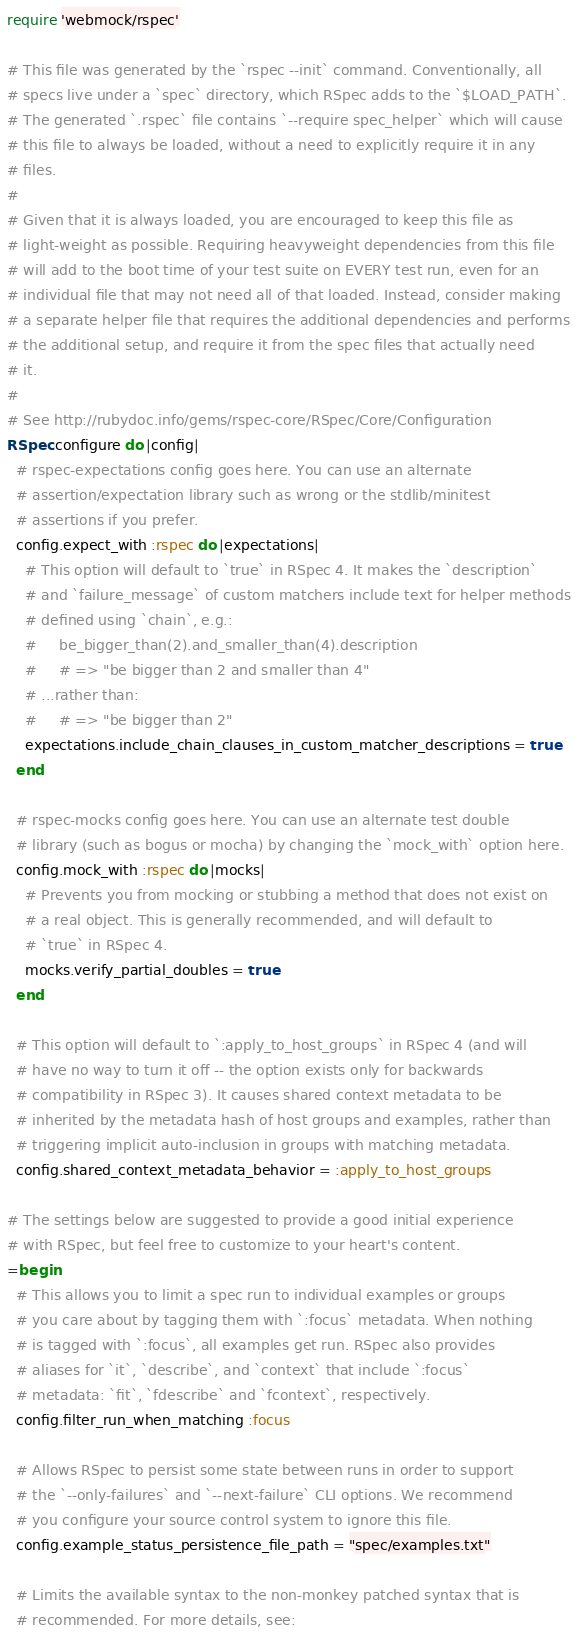Convert code to text. <code><loc_0><loc_0><loc_500><loc_500><_Ruby_>require 'webmock/rspec'

# This file was generated by the `rspec --init` command. Conventionally, all
# specs live under a `spec` directory, which RSpec adds to the `$LOAD_PATH`.
# The generated `.rspec` file contains `--require spec_helper` which will cause
# this file to always be loaded, without a need to explicitly require it in any
# files.
#
# Given that it is always loaded, you are encouraged to keep this file as
# light-weight as possible. Requiring heavyweight dependencies from this file
# will add to the boot time of your test suite on EVERY test run, even for an
# individual file that may not need all of that loaded. Instead, consider making
# a separate helper file that requires the additional dependencies and performs
# the additional setup, and require it from the spec files that actually need
# it.
#
# See http://rubydoc.info/gems/rspec-core/RSpec/Core/Configuration
RSpec.configure do |config|
  # rspec-expectations config goes here. You can use an alternate
  # assertion/expectation library such as wrong or the stdlib/minitest
  # assertions if you prefer.
  config.expect_with :rspec do |expectations|
    # This option will default to `true` in RSpec 4. It makes the `description`
    # and `failure_message` of custom matchers include text for helper methods
    # defined using `chain`, e.g.:
    #     be_bigger_than(2).and_smaller_than(4).description
    #     # => "be bigger than 2 and smaller than 4"
    # ...rather than:
    #     # => "be bigger than 2"
    expectations.include_chain_clauses_in_custom_matcher_descriptions = true
  end

  # rspec-mocks config goes here. You can use an alternate test double
  # library (such as bogus or mocha) by changing the `mock_with` option here.
  config.mock_with :rspec do |mocks|
    # Prevents you from mocking or stubbing a method that does not exist on
    # a real object. This is generally recommended, and will default to
    # `true` in RSpec 4.
    mocks.verify_partial_doubles = true
  end

  # This option will default to `:apply_to_host_groups` in RSpec 4 (and will
  # have no way to turn it off -- the option exists only for backwards
  # compatibility in RSpec 3). It causes shared context metadata to be
  # inherited by the metadata hash of host groups and examples, rather than
  # triggering implicit auto-inclusion in groups with matching metadata.
  config.shared_context_metadata_behavior = :apply_to_host_groups

# The settings below are suggested to provide a good initial experience
# with RSpec, but feel free to customize to your heart's content.
=begin
  # This allows you to limit a spec run to individual examples or groups
  # you care about by tagging them with `:focus` metadata. When nothing
  # is tagged with `:focus`, all examples get run. RSpec also provides
  # aliases for `it`, `describe`, and `context` that include `:focus`
  # metadata: `fit`, `fdescribe` and `fcontext`, respectively.
  config.filter_run_when_matching :focus

  # Allows RSpec to persist some state between runs in order to support
  # the `--only-failures` and `--next-failure` CLI options. We recommend
  # you configure your source control system to ignore this file.
  config.example_status_persistence_file_path = "spec/examples.txt"

  # Limits the available syntax to the non-monkey patched syntax that is
  # recommended. For more details, see:</code> 